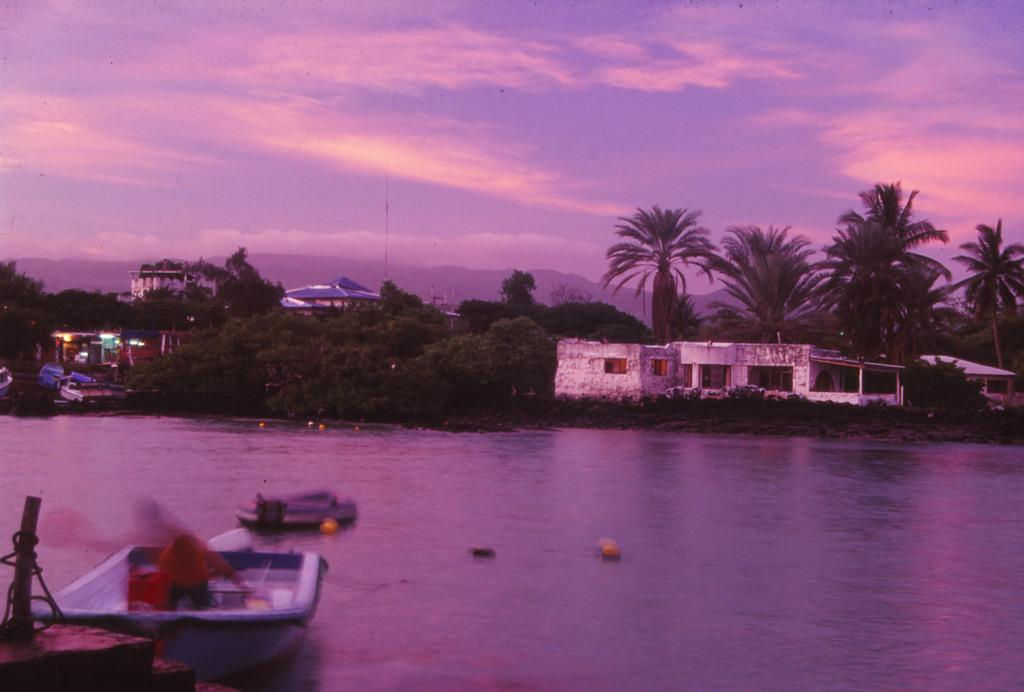What type of vehicles can be seen in the water in the image? There are boats in the water in the image. What type of natural elements can be seen in the image? Trees are visible in the image. What type of man-made structures can be seen in the image? There are buildings in the image. What part of the natural environment is visible in the image? The sky is visible in the image. What type of weather can be inferred from the image? Clouds are present in the sky, suggesting that it might be a partly cloudy day. What route do the boats take to reach the pleasure of the branch in the image? There is no mention of a route, pleasure, or branch in the image; it simply shows boats in the water, trees, buildings, and the sky. 